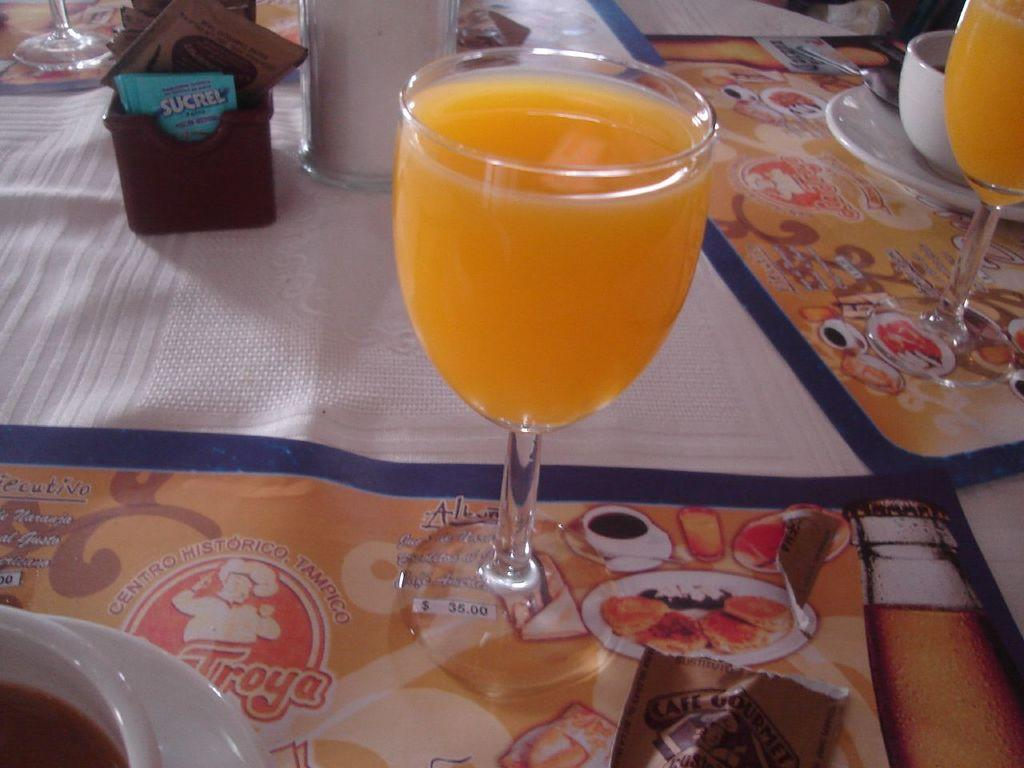What type of tableware can be seen in the image? There are two glasses of drinks, two cups, and two saucers in the image. What is located at the bottom of the image? There is a cloth at the bottom of the image. What type of cheese is being served on the mouth of the person in the image? There is no person or cheese present in the image. 